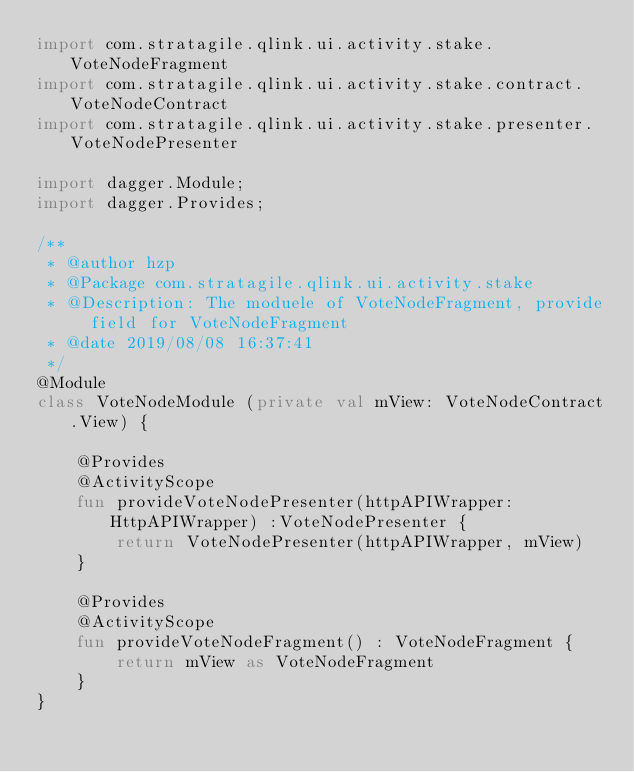<code> <loc_0><loc_0><loc_500><loc_500><_Kotlin_>import com.stratagile.qlink.ui.activity.stake.VoteNodeFragment
import com.stratagile.qlink.ui.activity.stake.contract.VoteNodeContract
import com.stratagile.qlink.ui.activity.stake.presenter.VoteNodePresenter

import dagger.Module;
import dagger.Provides;

/**
 * @author hzp
 * @Package com.stratagile.qlink.ui.activity.stake
 * @Description: The moduele of VoteNodeFragment, provide field for VoteNodeFragment
 * @date 2019/08/08 16:37:41
 */
@Module
class VoteNodeModule (private val mView: VoteNodeContract.View) {

    @Provides
    @ActivityScope
    fun provideVoteNodePresenter(httpAPIWrapper: HttpAPIWrapper) :VoteNodePresenter {
        return VoteNodePresenter(httpAPIWrapper, mView)
    }

    @Provides
    @ActivityScope
    fun provideVoteNodeFragment() : VoteNodeFragment {
        return mView as VoteNodeFragment
    }
}</code> 